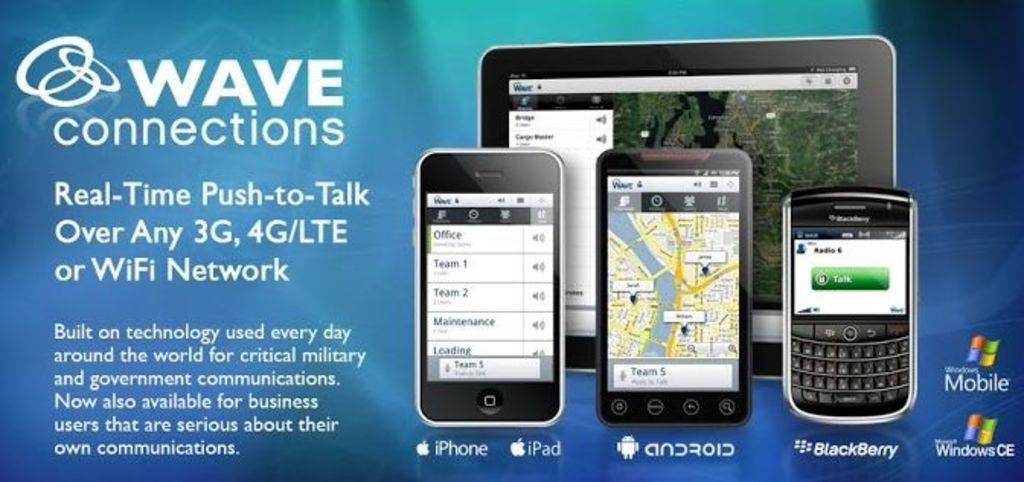<image>
Share a concise interpretation of the image provided. The app shown works on iphone ipad android and blackberry, 